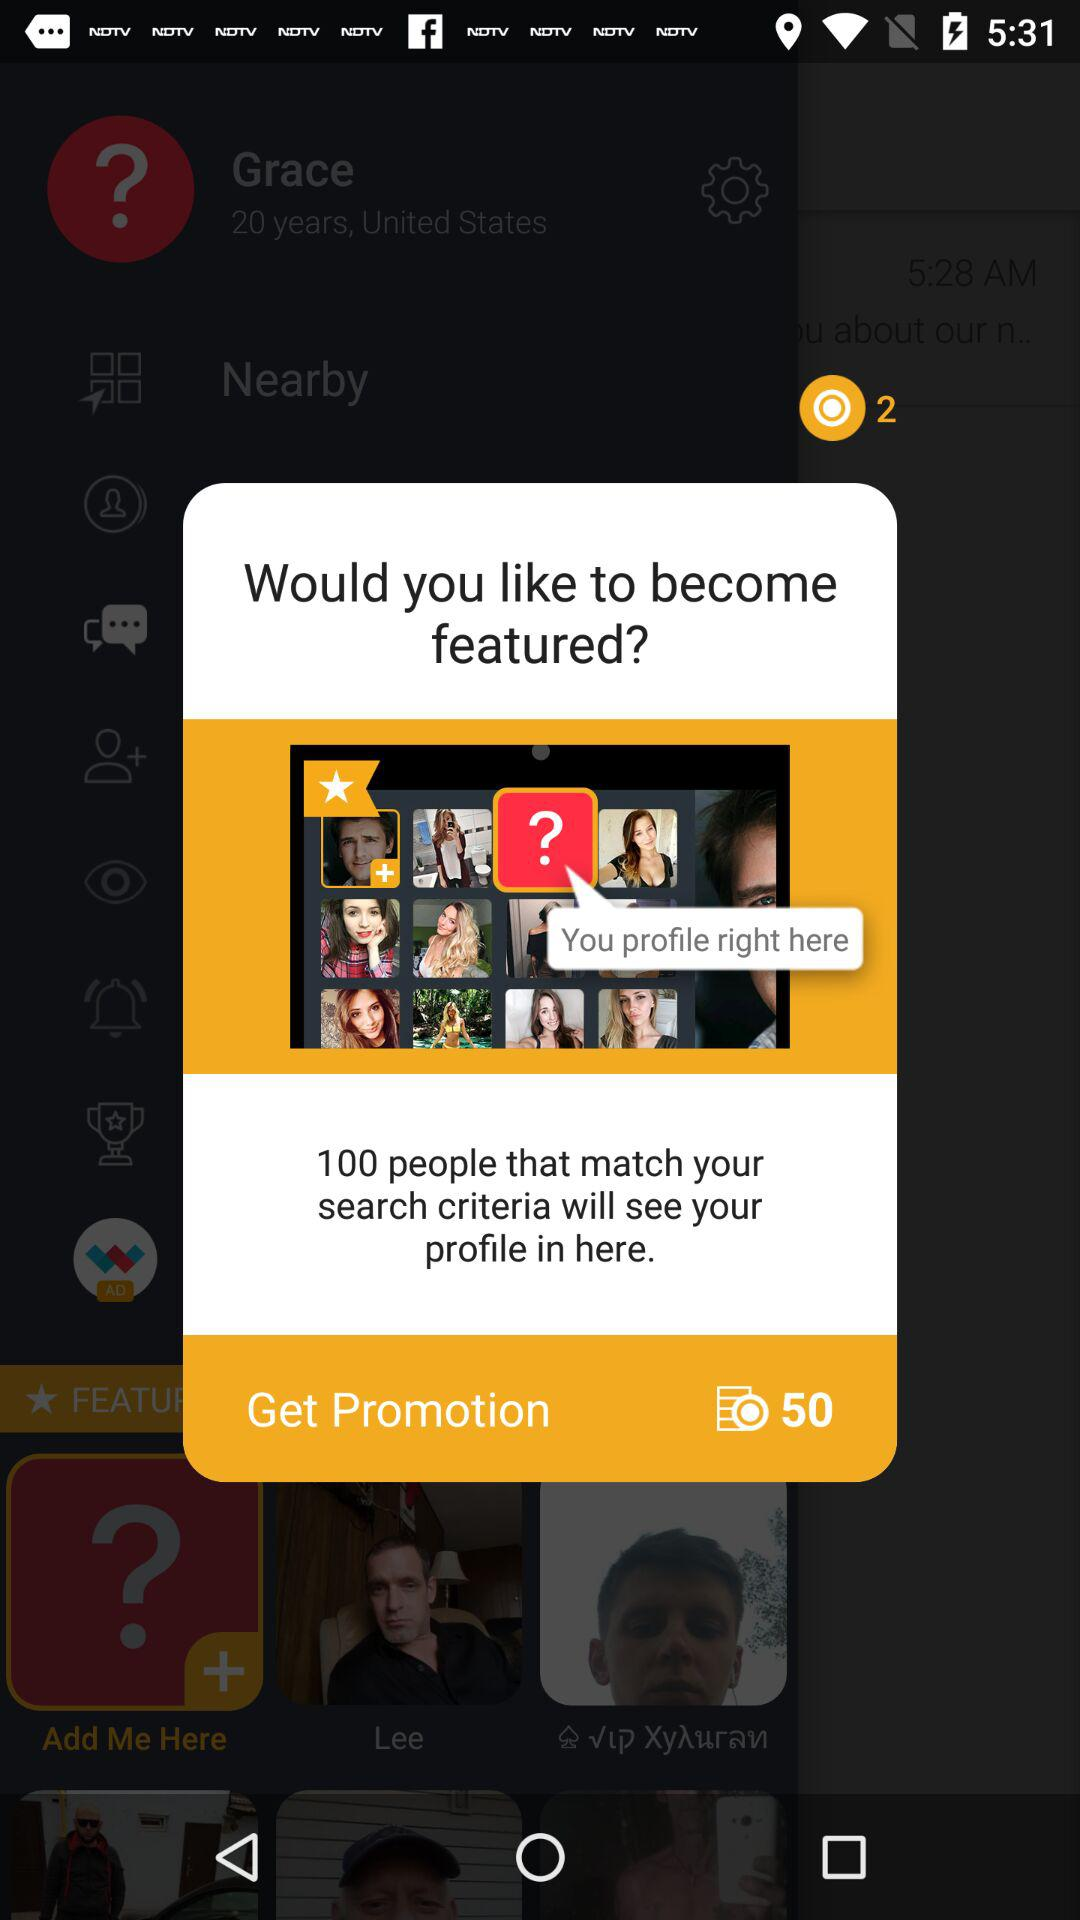How many people will see your profile if you become featured?
Answer the question using a single word or phrase. 100 